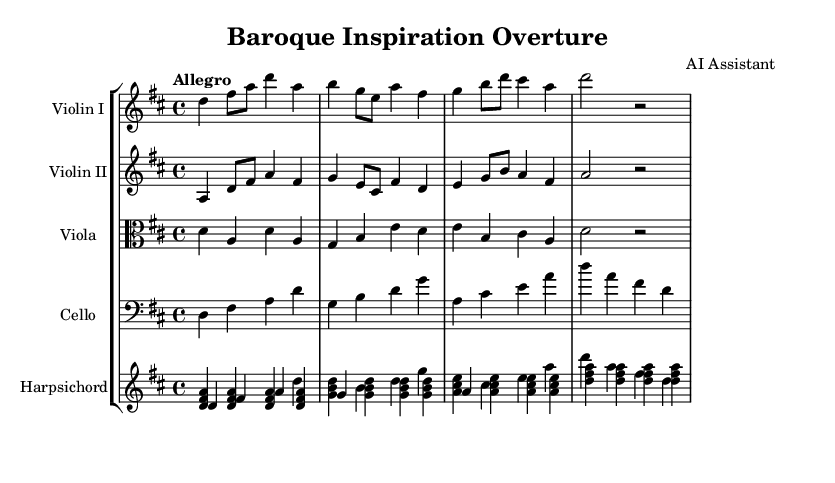What is the key signature of this music? The key signature is D major, which has two sharps: F# and C#.
Answer: D major What is the time signature of this music? The time signature is 4/4, indicating four beats per measure.
Answer: 4/4 What is the tempo marking given for this piece? The tempo marking is "Allegro," which indicates a fast and lively speed.
Answer: Allegro How many instruments are featured in this piece? The score includes four instruments: two violins, one viola, one cello, and one harpsichord.
Answer: Five Which instrument is playing the bass line? The cello plays the bass line, identified by the use of the bass clef.
Answer: Cello What melodic role does the first violin play compared to the second violin? The first violin carries the main theme, while the second violin provides a counter melody.
Answer: Main theme What is the primary compositional technique used in the overture? The overture employs imitation between the instruments, featuring interwoven melodies and harmonies.
Answer: Imitation 